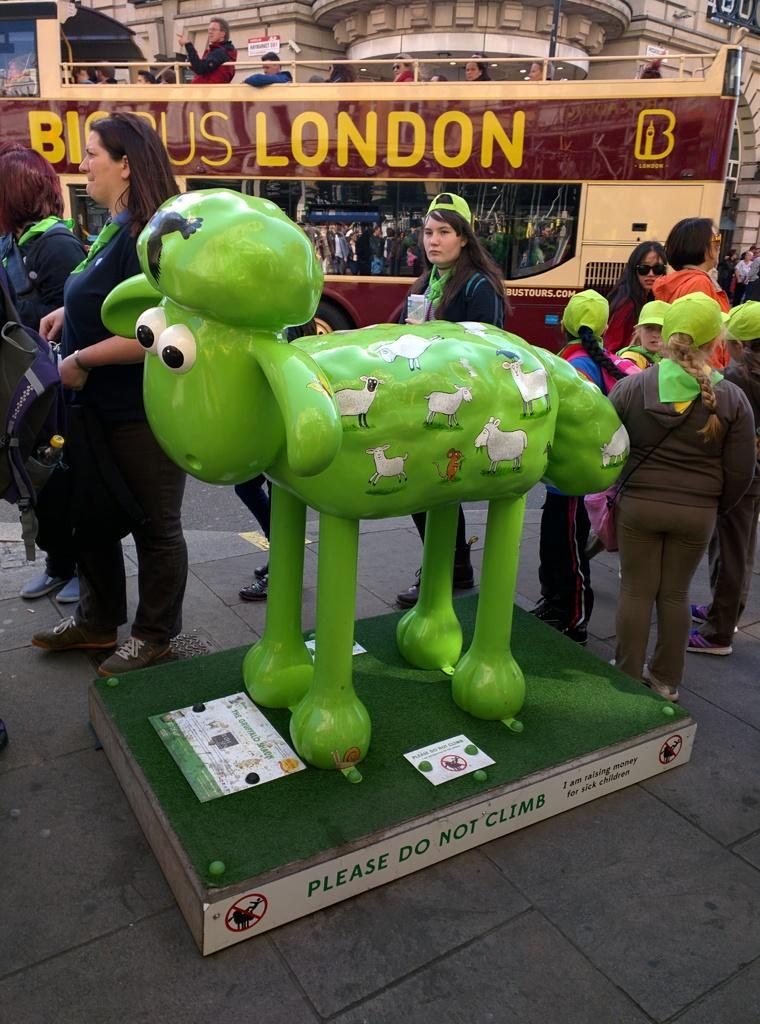Please provide a concise description of this image. In the image we can see there is a statue of sheep standing on the platform. There are other people standing on the ground and there is a vehicle parked on the road. There are people sitting in the vehicle and behind there is a building. 